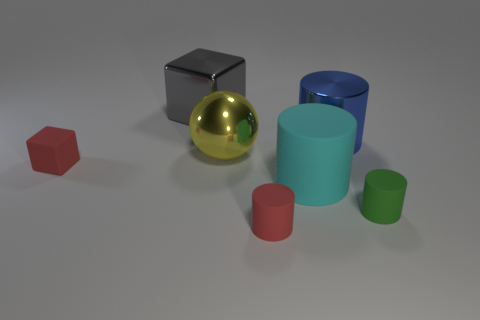Subtract all rubber cylinders. How many cylinders are left? 1 Subtract all red cylinders. How many cylinders are left? 3 Add 3 gray metal blocks. How many objects exist? 10 Subtract all brown cylinders. Subtract all blue spheres. How many cylinders are left? 4 Subtract all balls. How many objects are left? 6 Add 2 big cylinders. How many big cylinders exist? 4 Subtract 1 gray cubes. How many objects are left? 6 Subtract all small brown cubes. Subtract all yellow balls. How many objects are left? 6 Add 2 large blue shiny objects. How many large blue shiny objects are left? 3 